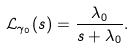<formula> <loc_0><loc_0><loc_500><loc_500>\mathcal { L } _ { \gamma _ { 0 } } ( s ) & = \frac { \lambda _ { 0 } } { s + \lambda _ { 0 } } .</formula> 